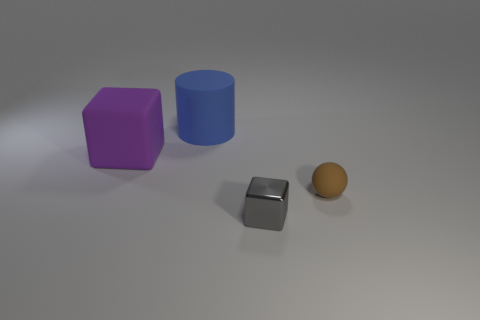There is a cube to the right of the cube to the left of the small gray object; what is its color?
Provide a succinct answer. Gray. There is a rubber thing on the right side of the large thing that is behind the big block; is there a purple rubber object on the left side of it?
Make the answer very short. Yes. What color is the large cylinder that is the same material as the purple cube?
Make the answer very short. Blue. How many large red blocks are the same material as the tiny ball?
Make the answer very short. 0. Are the purple block and the large blue object that is left of the brown matte sphere made of the same material?
Keep it short and to the point. Yes. What number of objects are objects that are behind the brown ball or tiny rubber objects?
Ensure brevity in your answer.  3. There is a matte object behind the large purple block that is on the left side of the big object to the right of the purple cube; how big is it?
Give a very brief answer. Large. Is there any other thing that has the same shape as the small brown thing?
Offer a terse response. No. What size is the block that is behind the block to the right of the blue cylinder?
Your answer should be compact. Large. What number of big objects are brown matte balls or gray blocks?
Ensure brevity in your answer.  0. 